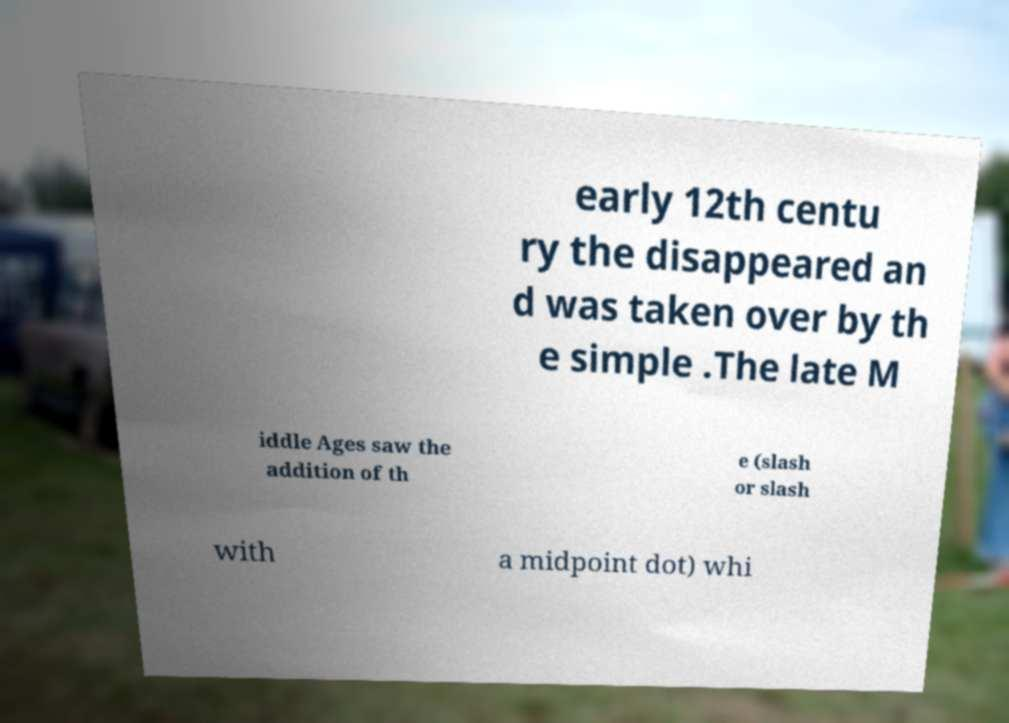Can you accurately transcribe the text from the provided image for me? early 12th centu ry the disappeared an d was taken over by th e simple .The late M iddle Ages saw the addition of th e (slash or slash with a midpoint dot) whi 